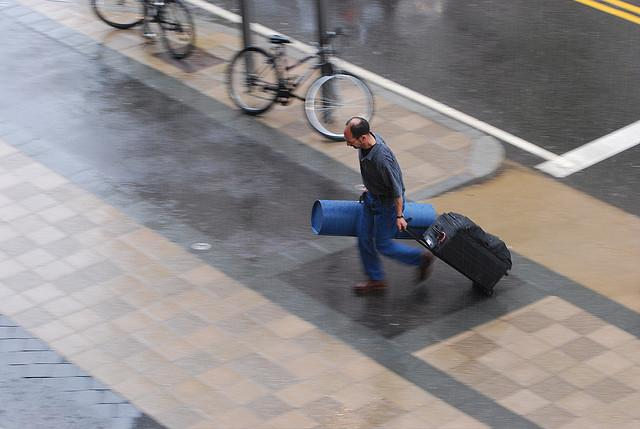What is the man transporting? luggage 